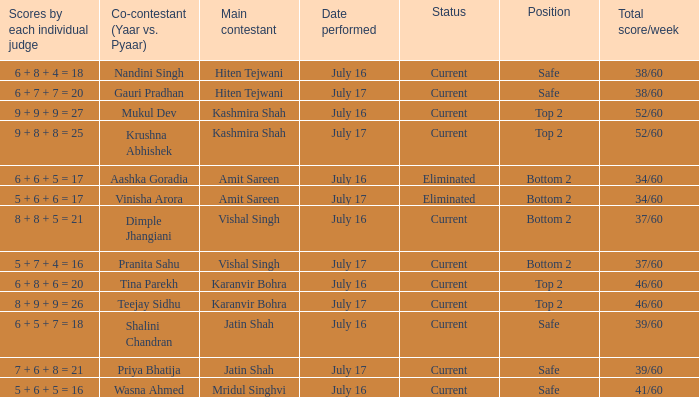Who performed with Tina Parekh? Karanvir Bohra. 